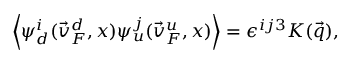Convert formula to latex. <formula><loc_0><loc_0><loc_500><loc_500>\left < \psi _ { d } ^ { i } ( \vec { v } _ { F } ^ { d } , x ) \psi _ { u } ^ { j } ( \vec { v } _ { F } ^ { u } , x ) \right > = \epsilon ^ { i j 3 } K ( \vec { q } ) ,</formula> 